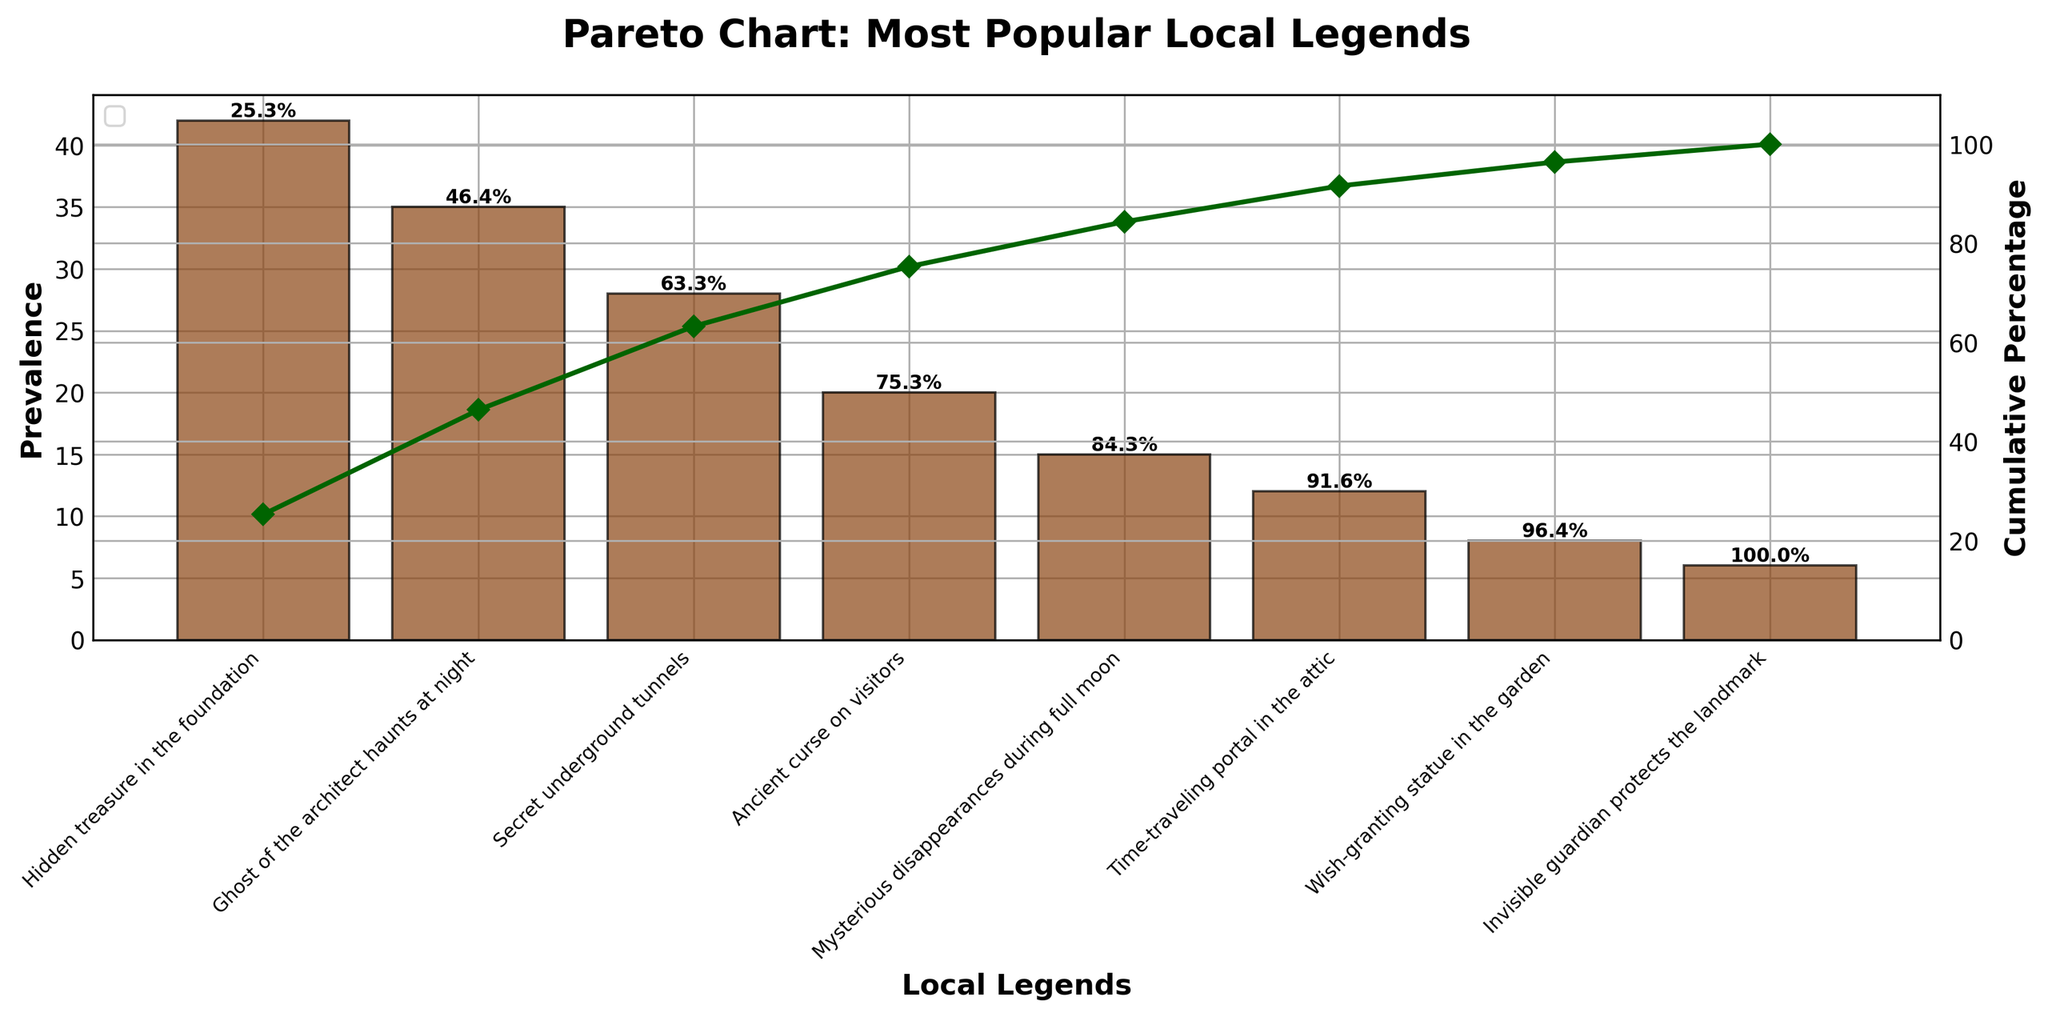What is the title of the figure? The title is usually displayed at the top of the figure, summarizing what the chart represents.
Answer: "Pareto Chart: Most Popular Local Legends" What does the x-axis represent in the chart? The x-axis displays the different local legends that are ordered by their prevalence, helping us understand which legends are most common.
Answer: Local Legends Which legend has the highest prevalence? By looking at the height of the bars, we can see that the "Hidden treasure in the foundation" legend has the tallest bar.
Answer: Hidden treasure in the foundation What is the cumulative percentage after the first three legends? The cumulative percentage is plotted on the secondary y-axis and marked above the bars. Adding the individual cumulative percentages of the first three legends (42%, 35%, and 28%) will give us this value.
Answer: 105% Which two legends are closest in terms of prevalence? By comparing the heights of the bars, we see that the "Time-traveling portal in the attic" (12) and "Wish-granting statue in the garden" (8) have the closest values.
Answer: Time-traveling portal in the attic and Wish-granting statue in the garden What is the prevalence value for the least common legend? By identifying the shortest bar in the chart for "Invisible guardian protects the landmark," we can see its value on the y-axis.
Answer: 6 How many legends have a prevalence of 15 or higher? We can count the number of bars that have a height equal to or greater than 15 by comparing their heights against the y-axis values.
Answer: 5 What cumulative percentage does the first legend achieve on its own? Refer to the cumulative percentage value directly above the bar representing the "Hidden treasure in the foundation."
Answer: 42% By how much does the cumulative percentage increase from the second to the third legend? The cumulative percentage of the second legend is 77% and that of the third legend is 105%. The increase is the difference between these two percentages.
Answer: 28% What color are the bars in the chart? The bars in the chart are all the same color; by observing its appearance, they are a shade of brown.
Answer: Brown 